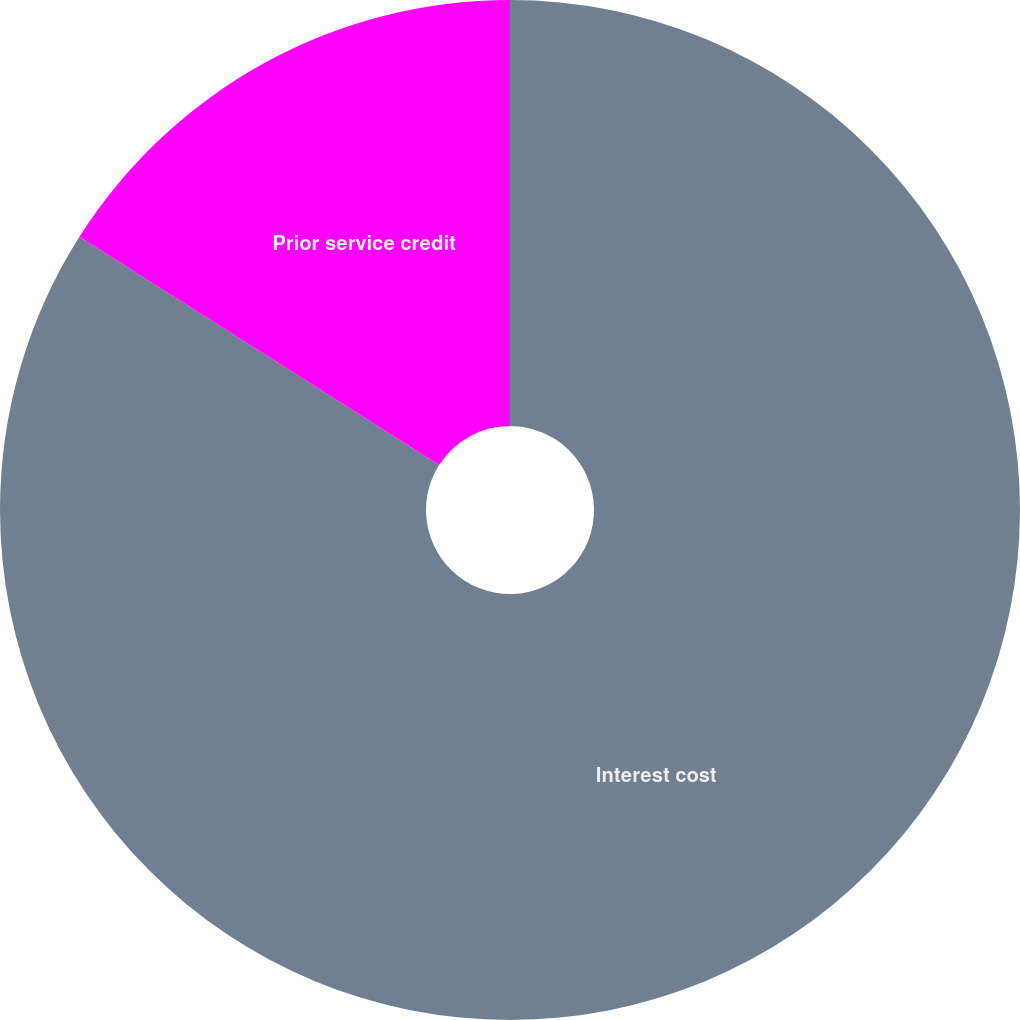<chart> <loc_0><loc_0><loc_500><loc_500><pie_chart><fcel>Interest cost<fcel>Prior service credit<nl><fcel>84.0%<fcel>16.0%<nl></chart> 